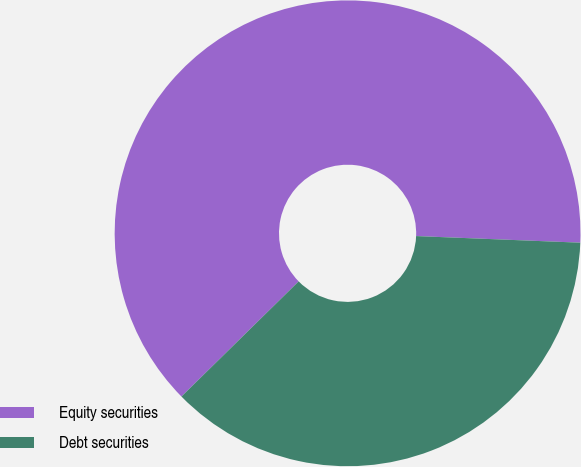Convert chart to OTSL. <chart><loc_0><loc_0><loc_500><loc_500><pie_chart><fcel>Equity securities<fcel>Debt securities<nl><fcel>63.0%<fcel>37.0%<nl></chart> 